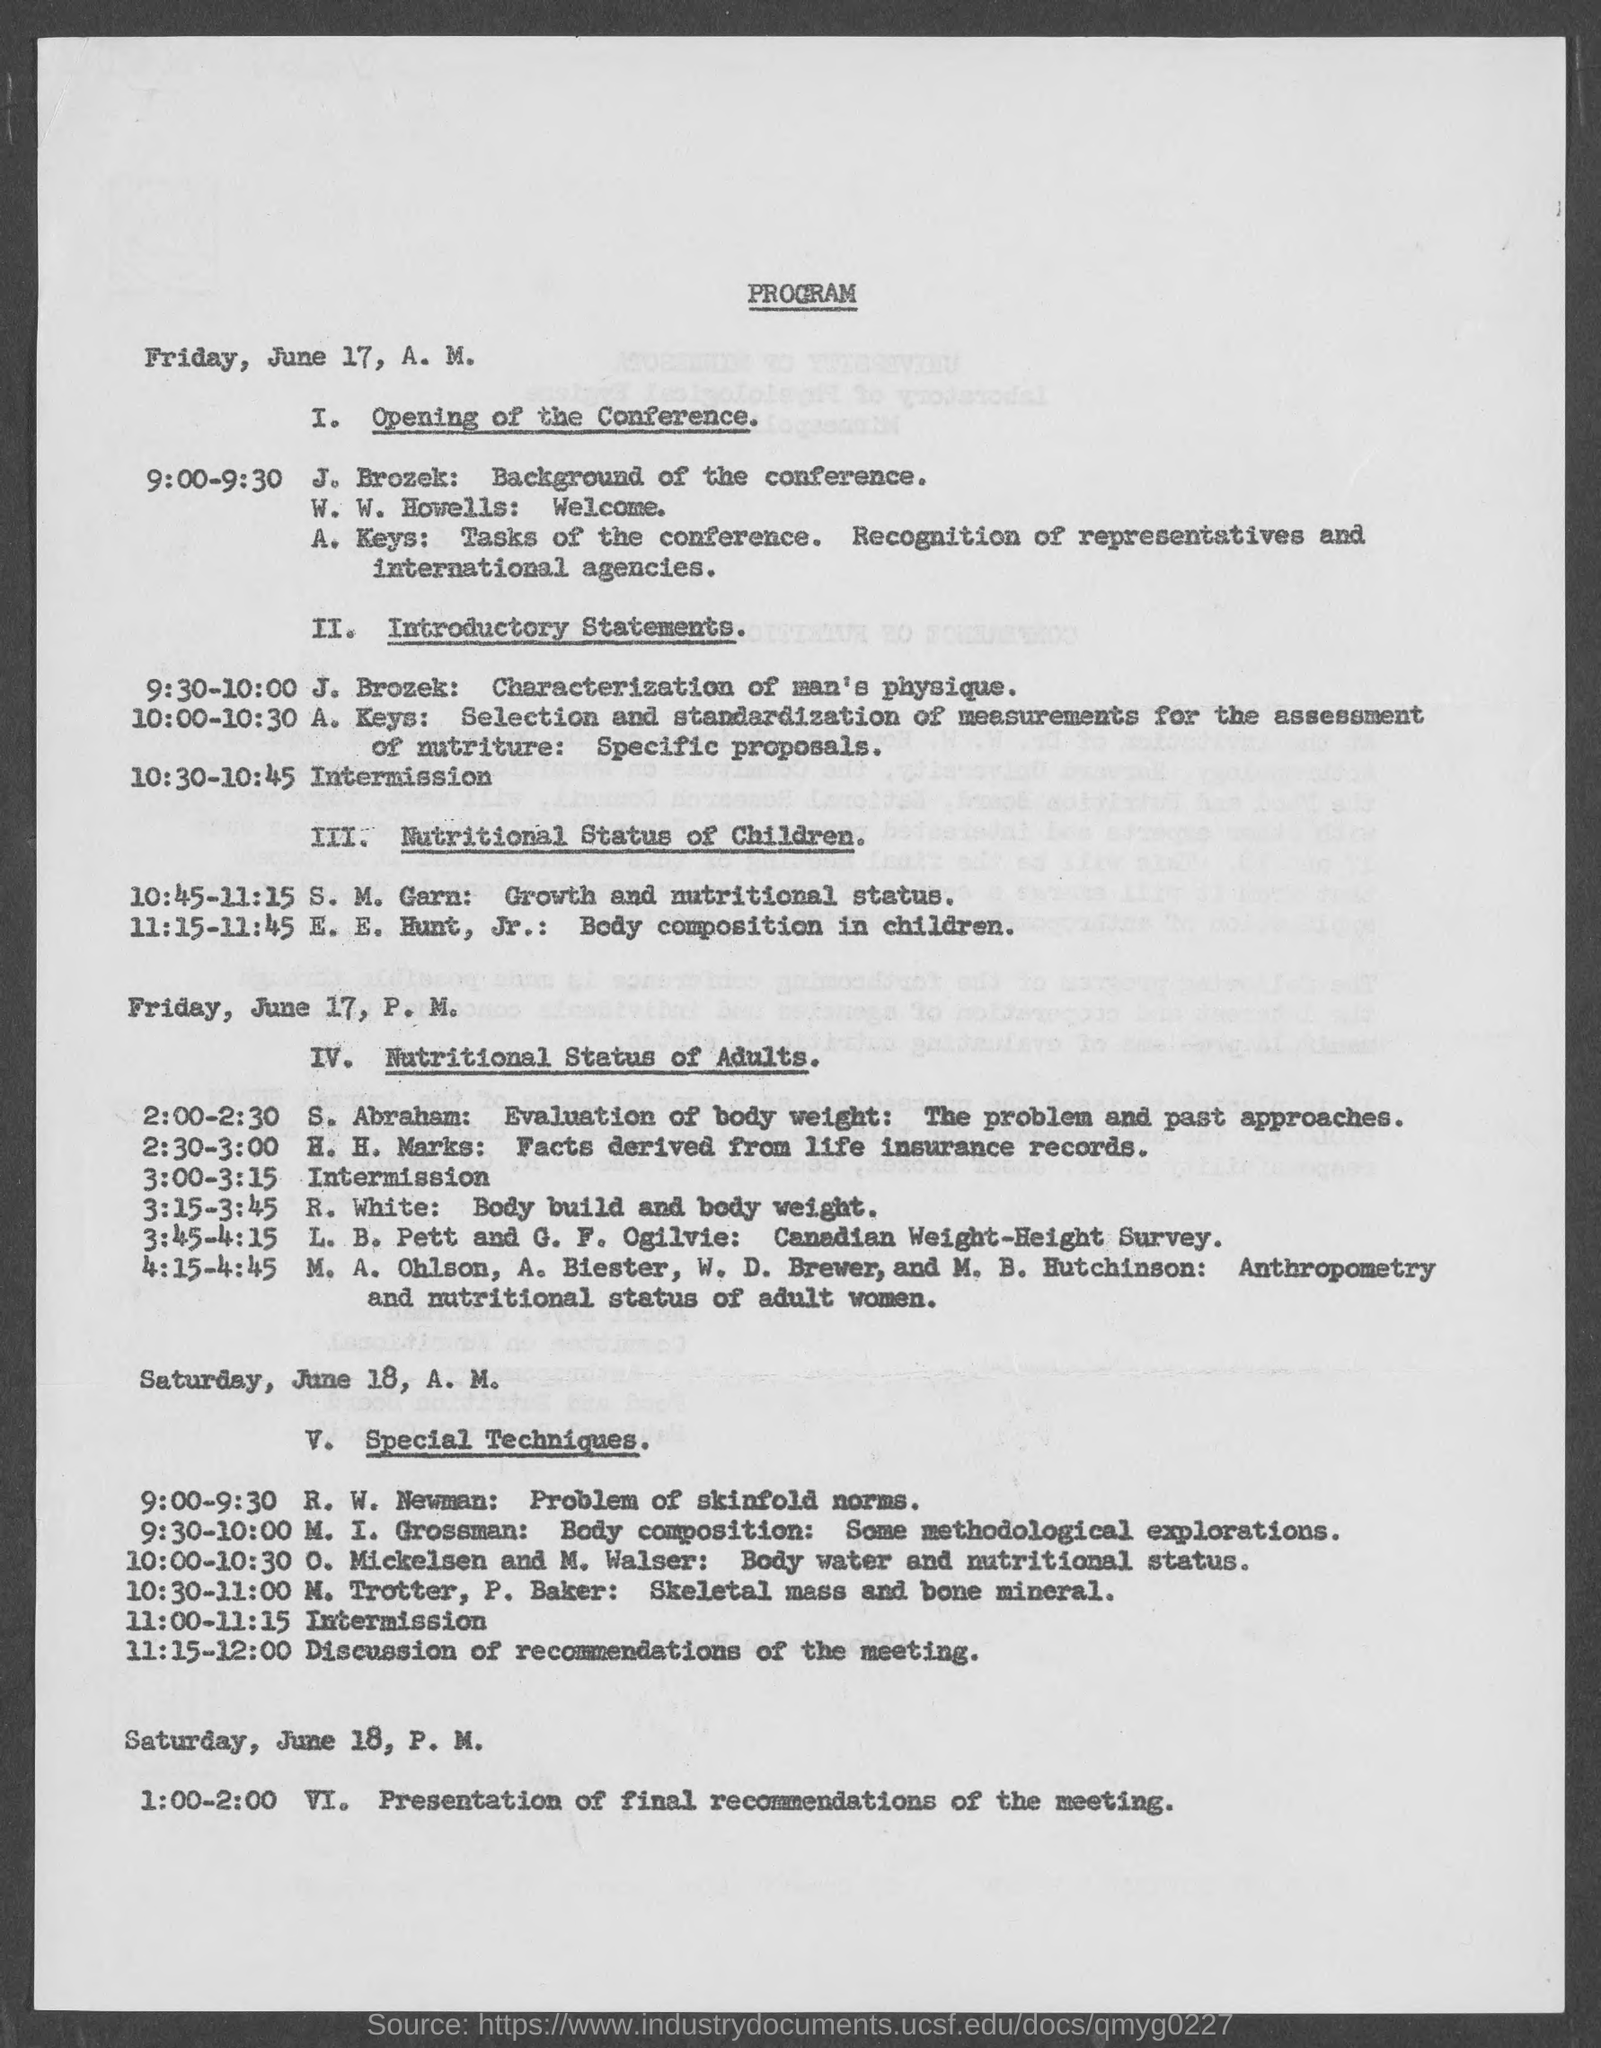What is J. Brozek's topic from 9:30-10:00?
Offer a terse response. CHARACTERIZATION OF MAN'S PHYSIQUE. 